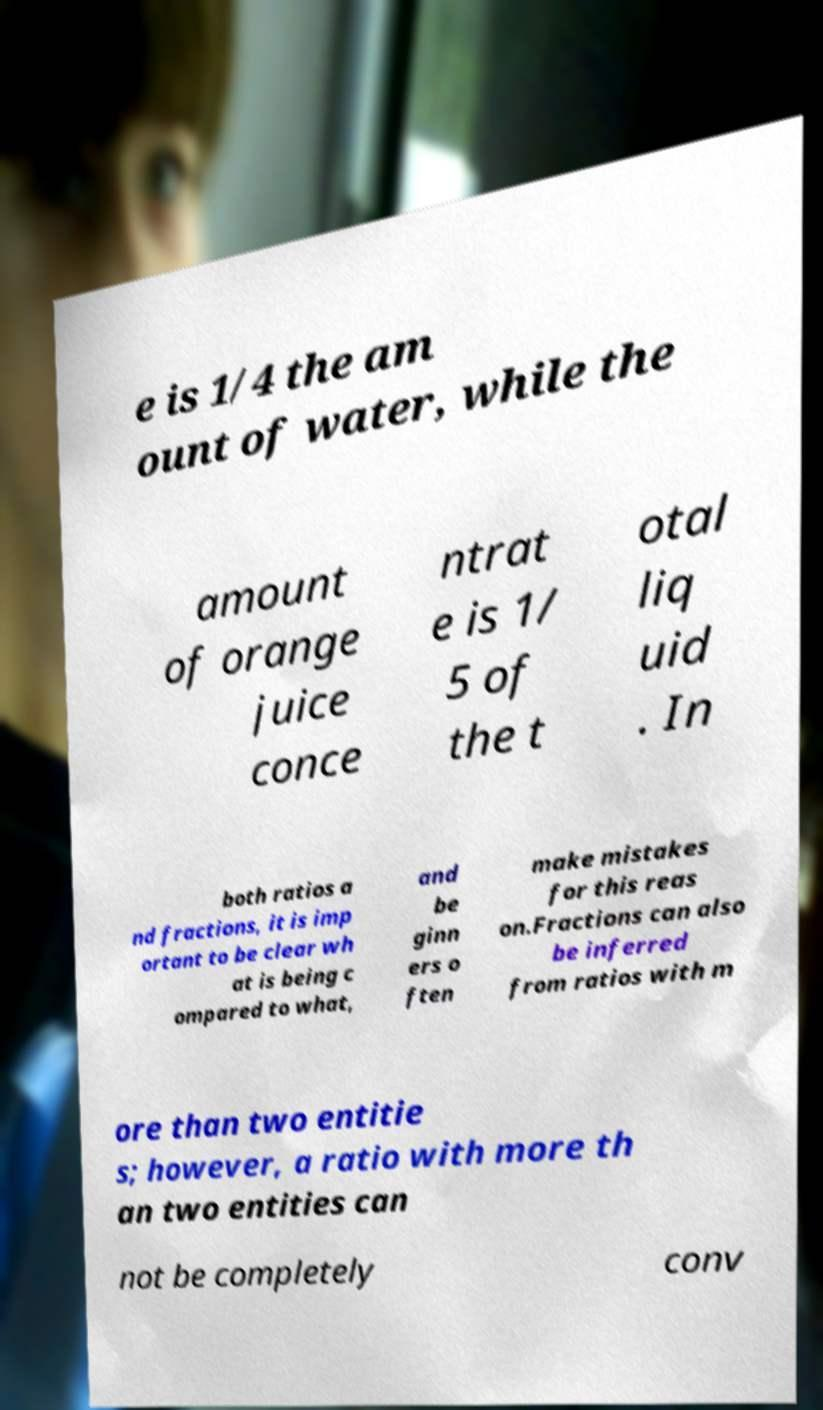Could you assist in decoding the text presented in this image and type it out clearly? e is 1/4 the am ount of water, while the amount of orange juice conce ntrat e is 1/ 5 of the t otal liq uid . In both ratios a nd fractions, it is imp ortant to be clear wh at is being c ompared to what, and be ginn ers o ften make mistakes for this reas on.Fractions can also be inferred from ratios with m ore than two entitie s; however, a ratio with more th an two entities can not be completely conv 